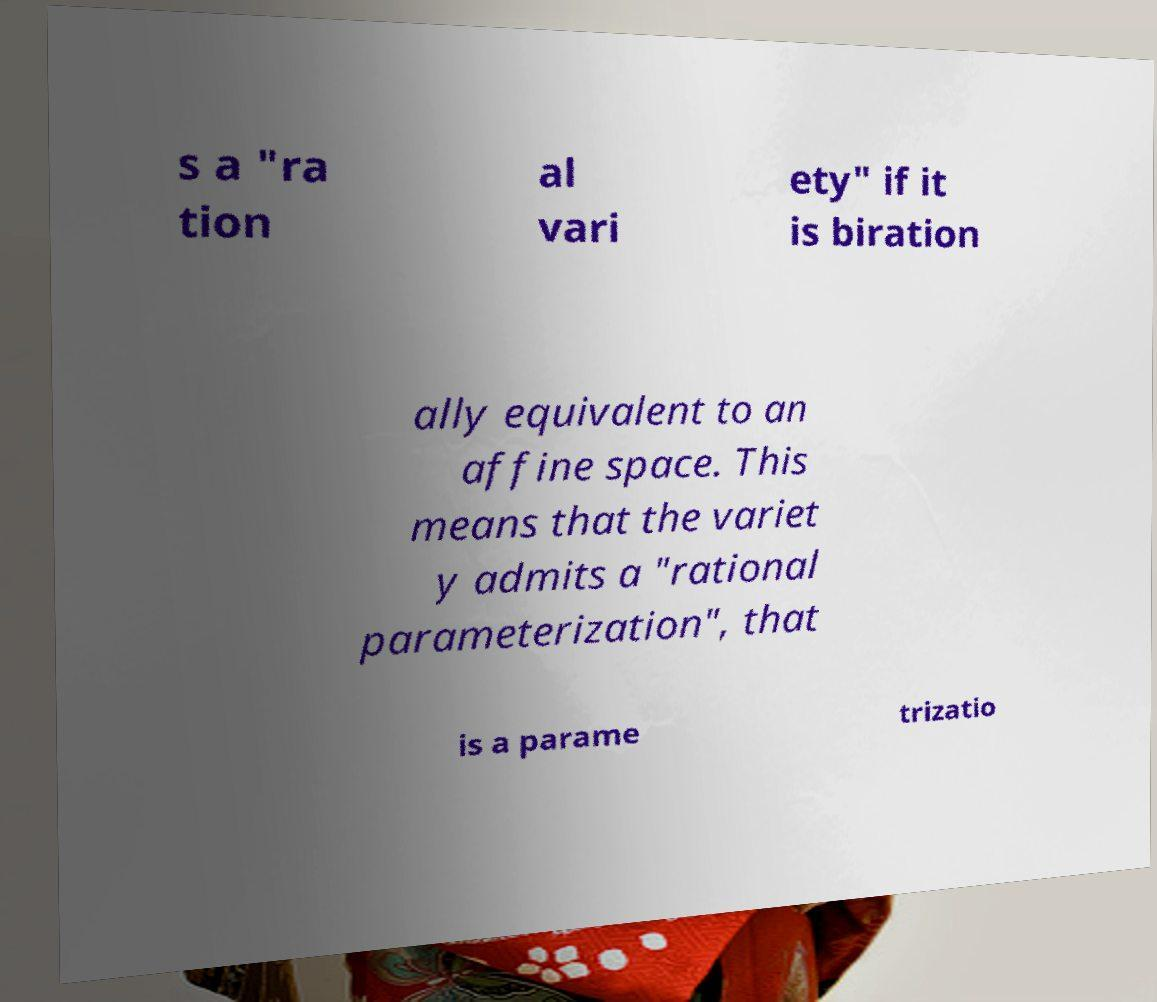For documentation purposes, I need the text within this image transcribed. Could you provide that? s a "ra tion al vari ety" if it is biration ally equivalent to an affine space. This means that the variet y admits a "rational parameterization", that is a parame trizatio 